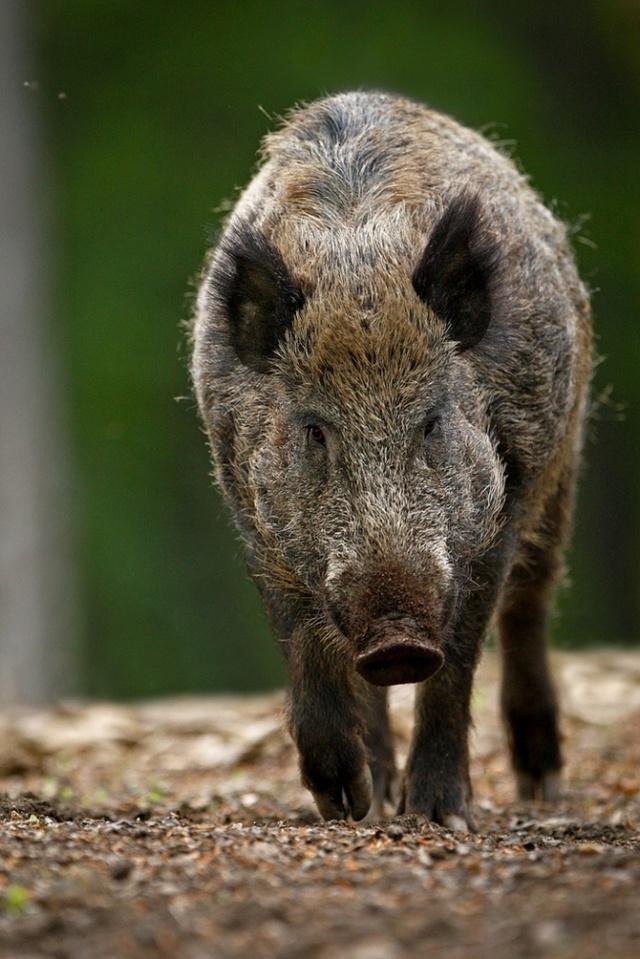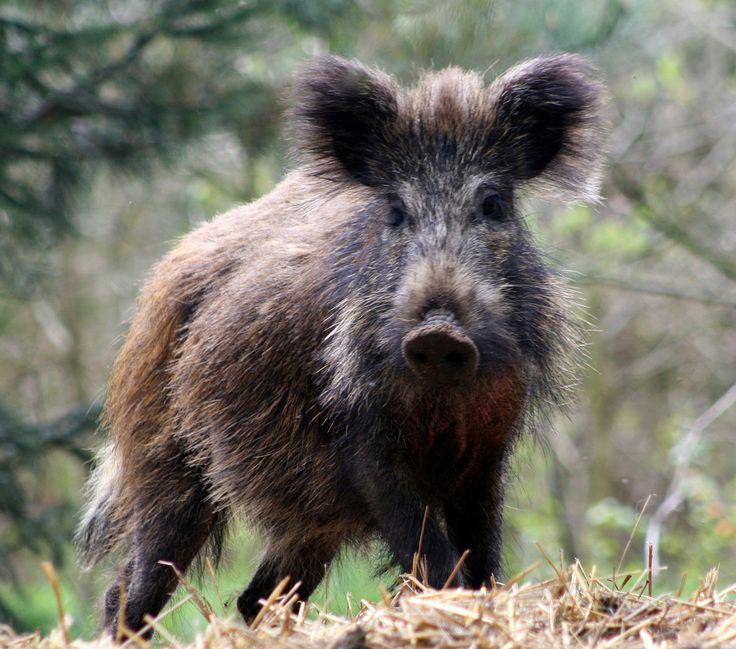The first image is the image on the left, the second image is the image on the right. Examine the images to the left and right. Is the description "One image shows a forward-turned wild pig without visible tusks, standing on elevated ground and looking downward." accurate? Answer yes or no. Yes. 